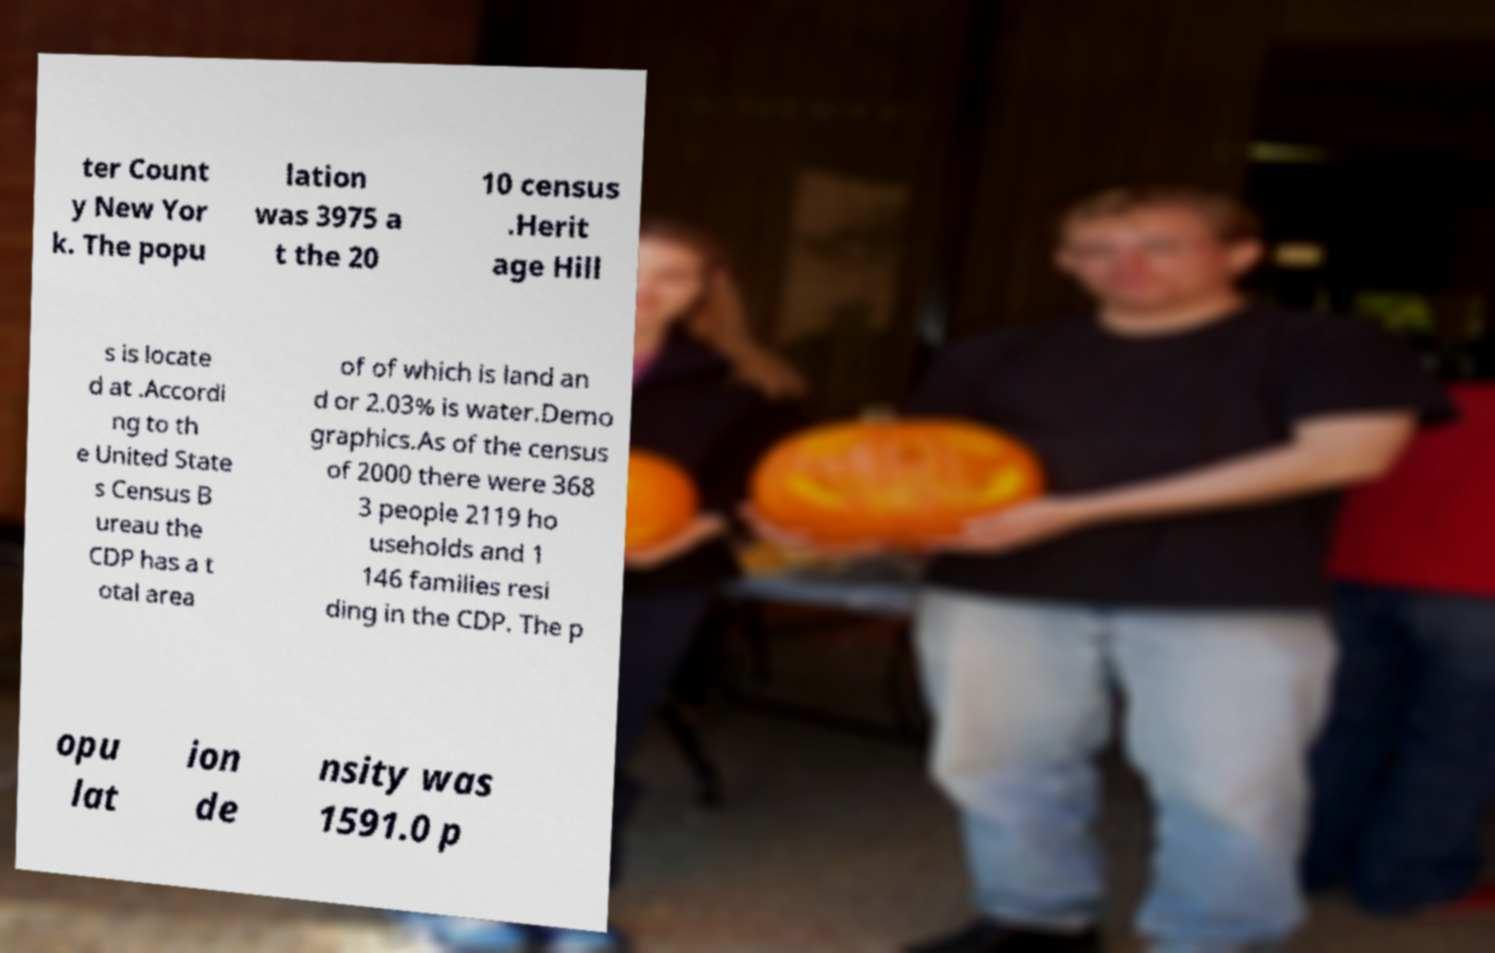Could you assist in decoding the text presented in this image and type it out clearly? ter Count y New Yor k. The popu lation was 3975 a t the 20 10 census .Herit age Hill s is locate d at .Accordi ng to th e United State s Census B ureau the CDP has a t otal area of of which is land an d or 2.03% is water.Demo graphics.As of the census of 2000 there were 368 3 people 2119 ho useholds and 1 146 families resi ding in the CDP. The p opu lat ion de nsity was 1591.0 p 